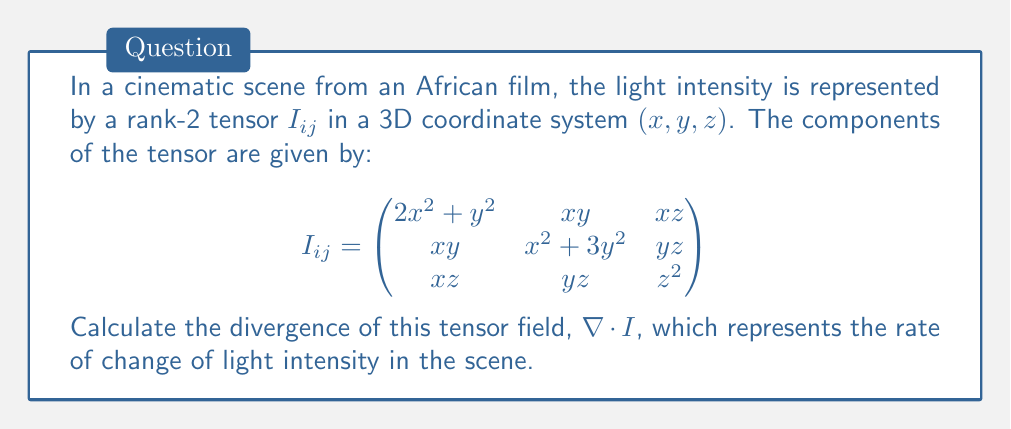Solve this math problem. To calculate the divergence of the tensor field, we need to follow these steps:

1) The divergence of a rank-2 tensor in 3D is given by:

   $$\nabla \cdot I = \frac{\partial I_{xx}}{\partial x} + \frac{\partial I_{yy}}{\partial y} + \frac{\partial I_{zz}}{\partial z}$$

2) Let's calculate each term:

   a) $\frac{\partial I_{xx}}{\partial x}$:
      $I_{xx} = 2x^2 + y^2$
      $\frac{\partial I_{xx}}{\partial x} = 4x$

   b) $\frac{\partial I_{yy}}{\partial y}$:
      $I_{yy} = x^2 + 3y^2$
      $\frac{\partial I_{yy}}{\partial y} = 6y$

   c) $\frac{\partial I_{zz}}{\partial z}$:
      $I_{zz} = z^2$
      $\frac{\partial I_{zz}}{\partial z} = 2z$

3) Now, we sum these terms:

   $$\nabla \cdot I = 4x + 6y + 2z$$

This result represents the rate of change of light intensity in the cinematic scene along all three dimensions.
Answer: $\nabla \cdot I = 4x + 6y + 2z$ 